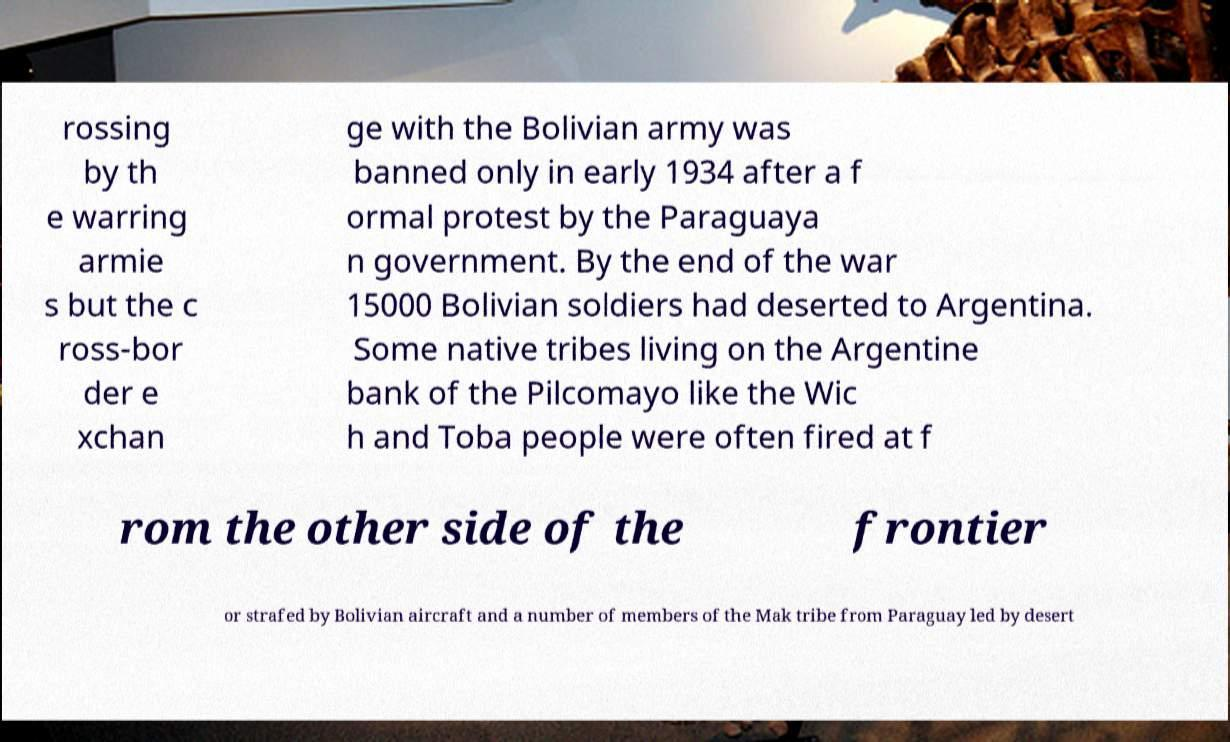Please read and relay the text visible in this image. What does it say? rossing by th e warring armie s but the c ross-bor der e xchan ge with the Bolivian army was banned only in early 1934 after a f ormal protest by the Paraguaya n government. By the end of the war 15000 Bolivian soldiers had deserted to Argentina. Some native tribes living on the Argentine bank of the Pilcomayo like the Wic h and Toba people were often fired at f rom the other side of the frontier or strafed by Bolivian aircraft and a number of members of the Mak tribe from Paraguay led by desert 